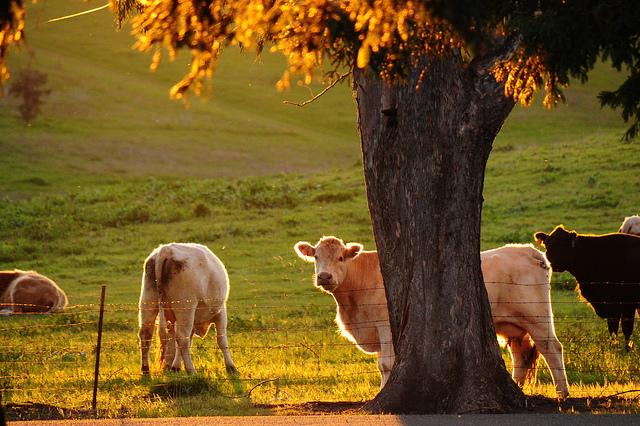What is one of the cows hiding behind? tree 